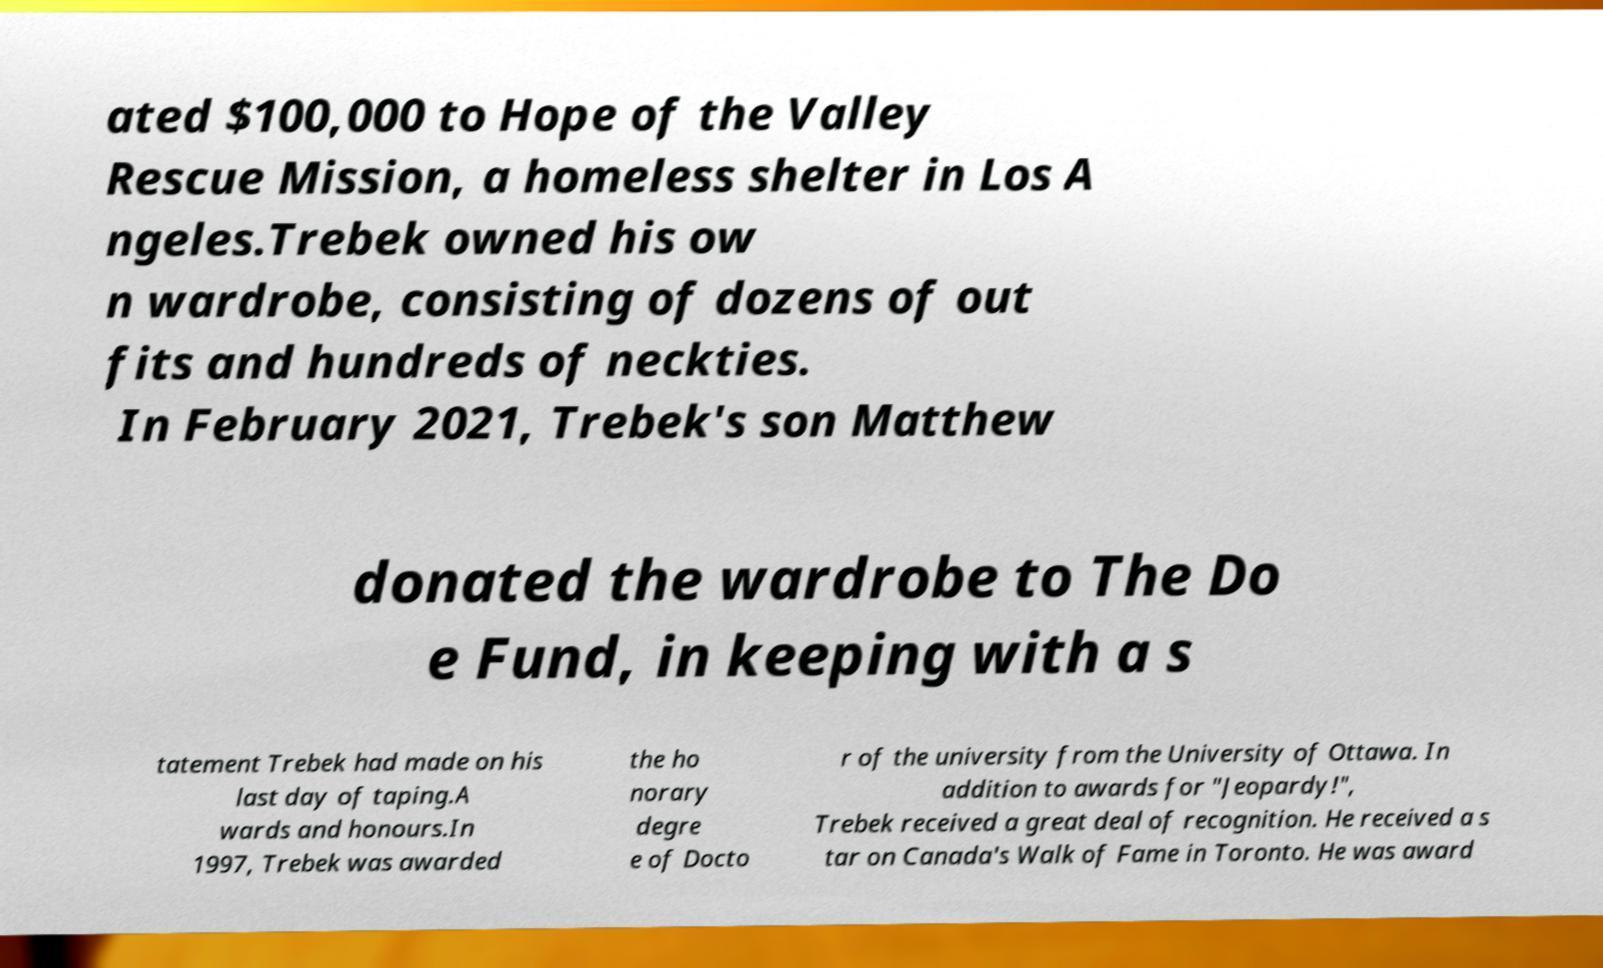There's text embedded in this image that I need extracted. Can you transcribe it verbatim? ated $100,000 to Hope of the Valley Rescue Mission, a homeless shelter in Los A ngeles.Trebek owned his ow n wardrobe, consisting of dozens of out fits and hundreds of neckties. In February 2021, Trebek's son Matthew donated the wardrobe to The Do e Fund, in keeping with a s tatement Trebek had made on his last day of taping.A wards and honours.In 1997, Trebek was awarded the ho norary degre e of Docto r of the university from the University of Ottawa. In addition to awards for "Jeopardy!", Trebek received a great deal of recognition. He received a s tar on Canada's Walk of Fame in Toronto. He was award 